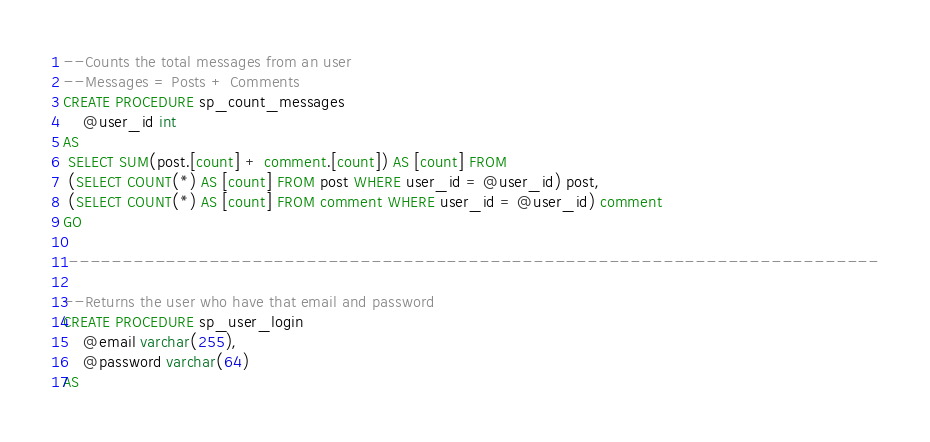Convert code to text. <code><loc_0><loc_0><loc_500><loc_500><_SQL_>--Counts the total messages from an user
--Messages = Posts + Comments
CREATE PROCEDURE sp_count_messages
	@user_id int
AS
 SELECT SUM(post.[count] + comment.[count]) AS [count] FROM
 (SELECT COUNT(*) AS [count] FROM post WHERE user_id = @user_id) post,
 (SELECT COUNT(*) AS [count] FROM comment WHERE user_id = @user_id) comment
GO

 ---------------------------------------------------------------------------

--Returns the user who have that email and password
CREATE PROCEDURE sp_user_login
	@email varchar(255),
	@password varchar(64)
AS</code> 